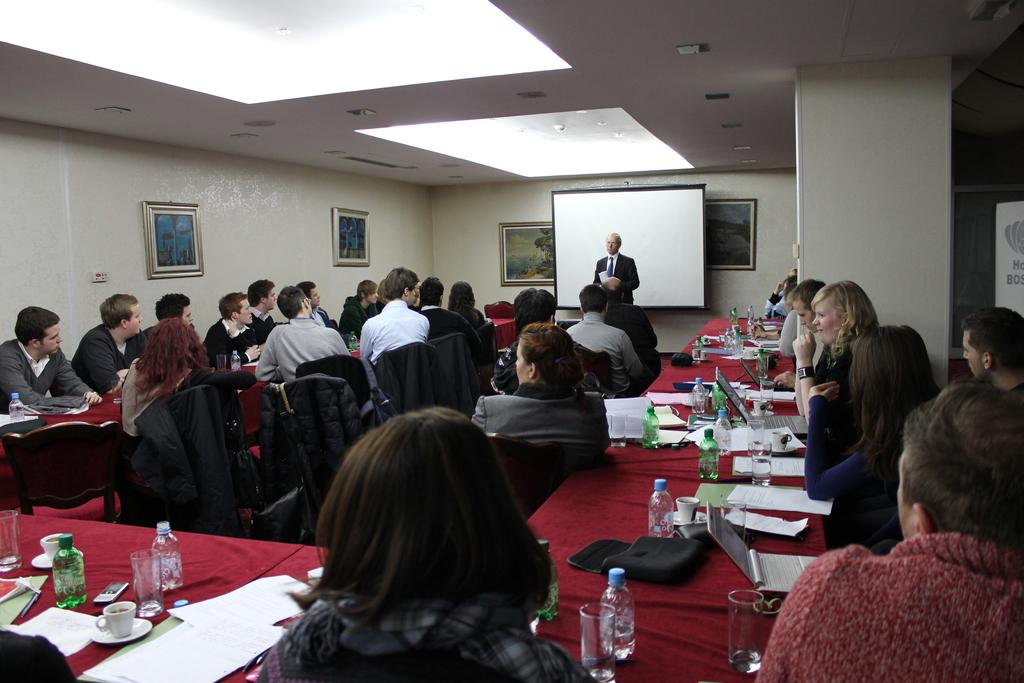What are the people in the image doing? There is a group of people sitting at a table in the image. What are the people sitting on? The people are sitting in chairs. Is there anyone standing in the image? Yes, there is a man standing in the image. What is the man doing? The man is speaking to the group of people. What type of pickle is being passed around the table in the image? There is no pickle present in the image; it features a group of people sitting at a table and a man standing. 